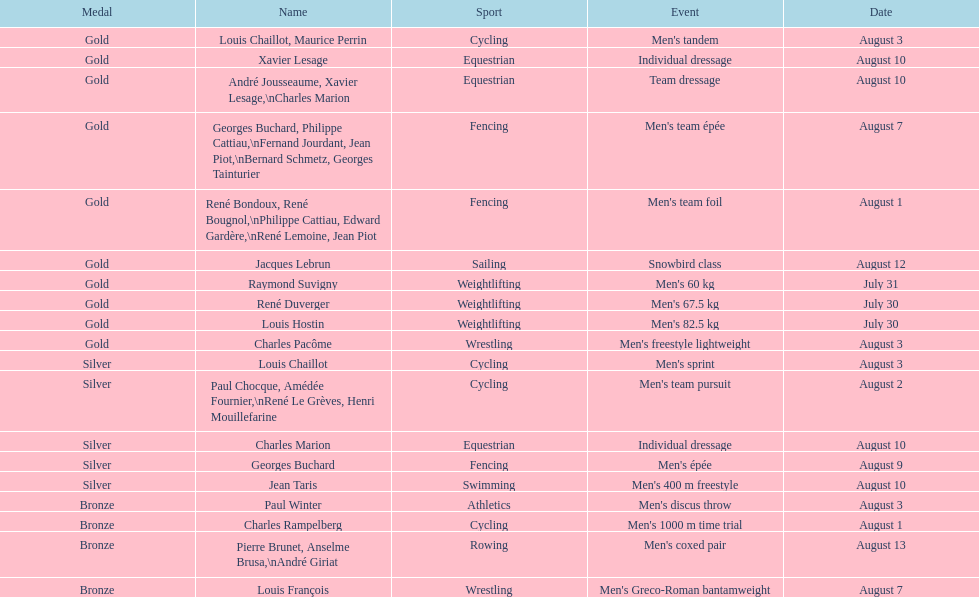Right before team dressage, what event is listed? Individual dressage. 